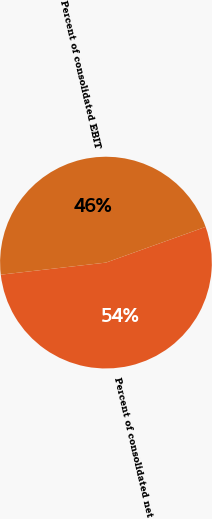Convert chart to OTSL. <chart><loc_0><loc_0><loc_500><loc_500><pie_chart><fcel>Percent of consolidated net<fcel>Percent of consolidated EBIT<nl><fcel>53.66%<fcel>46.34%<nl></chart> 